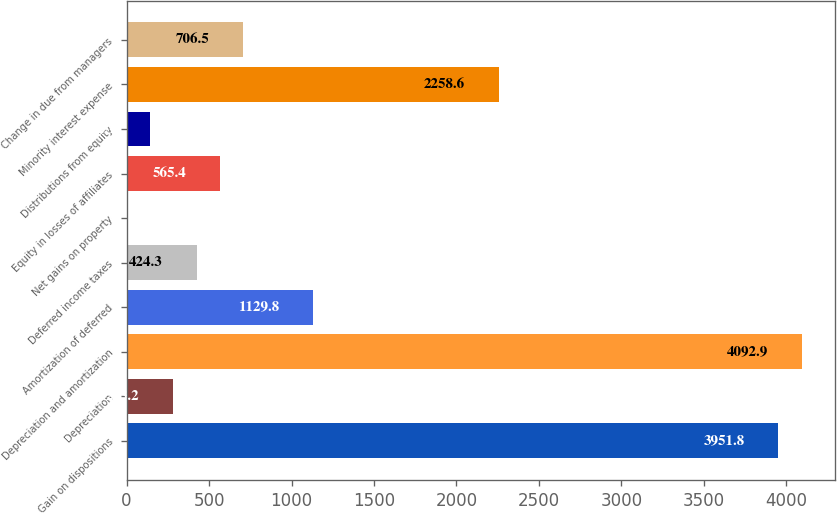<chart> <loc_0><loc_0><loc_500><loc_500><bar_chart><fcel>Gain on dispositions<fcel>Depreciation<fcel>Depreciation and amortization<fcel>Amortization of deferred<fcel>Deferred income taxes<fcel>Net gains on property<fcel>Equity in losses of affiliates<fcel>Distributions from equity<fcel>Minority interest expense<fcel>Change in due from managers<nl><fcel>3951.8<fcel>283.2<fcel>4092.9<fcel>1129.8<fcel>424.3<fcel>1<fcel>565.4<fcel>142.1<fcel>2258.6<fcel>706.5<nl></chart> 